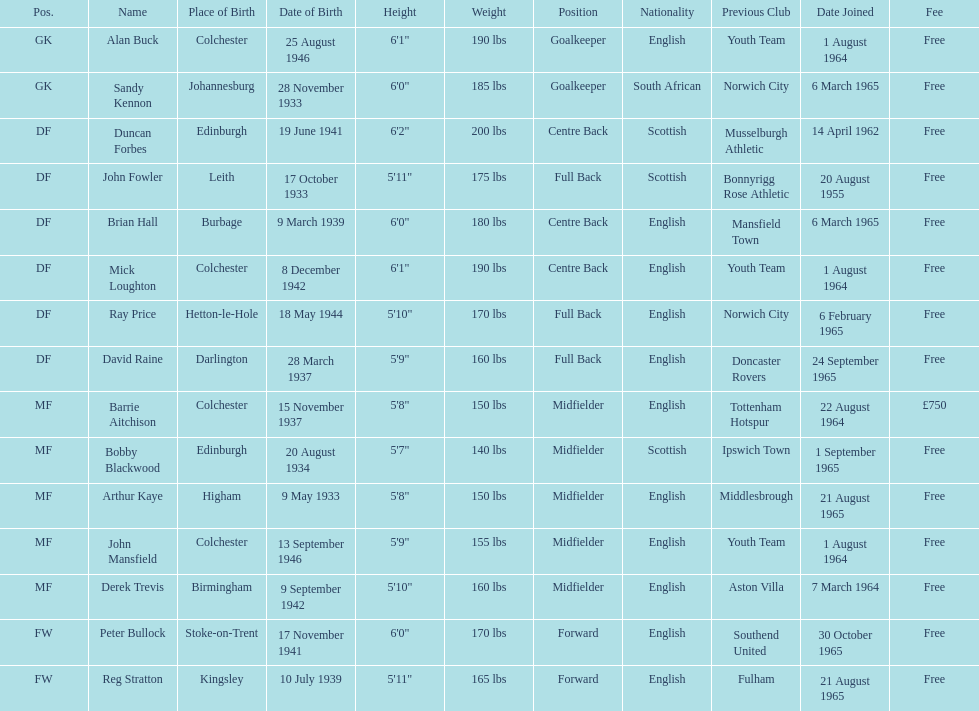How many players are listed as df? 6. 